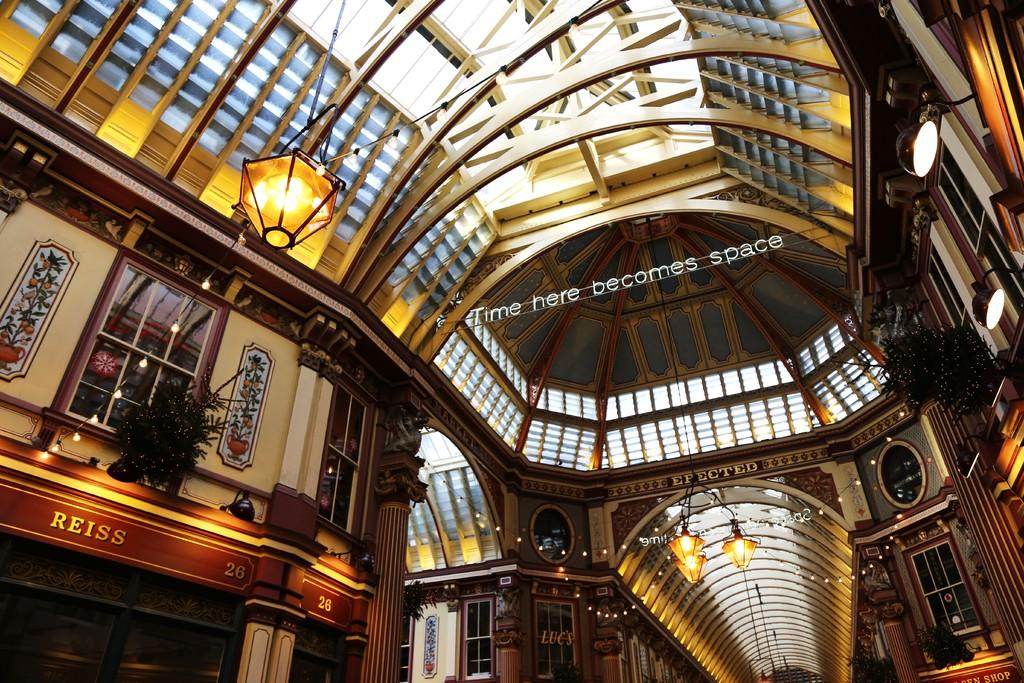What type of structure is visible in the image? There is a roof, lights, pillars, windows, and walls visible in the image, which suggests a building or structure. Can you describe the architectural features of the structure? The structure has pillars, windows, and walls. What else can be seen in the image besides the structure? There are plants and some text in the middle of the image. What type of stamp can be seen on the roof of the structure in the image? There is no stamp present on the roof of the structure in the image. How many people are in the group standing near the structure? There is no group of people present near the structure in the image. 